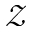<formula> <loc_0><loc_0><loc_500><loc_500>\mathcal { Z }</formula> 